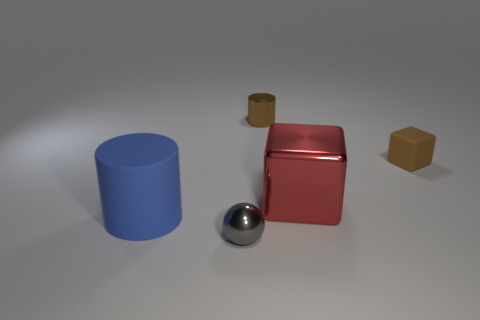What lighting technique might have been used in this scene to create such soft shadows? The soft shadows hint at a diffuse lighting setup, often achieved through global illumination techniques or by using large, soft light sources that scatter light, minimizing harsh shadows. 